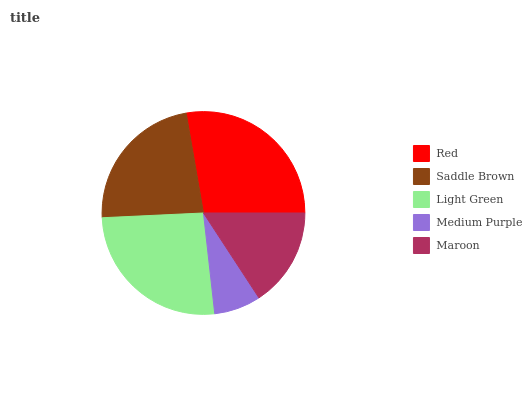Is Medium Purple the minimum?
Answer yes or no. Yes. Is Red the maximum?
Answer yes or no. Yes. Is Saddle Brown the minimum?
Answer yes or no. No. Is Saddle Brown the maximum?
Answer yes or no. No. Is Red greater than Saddle Brown?
Answer yes or no. Yes. Is Saddle Brown less than Red?
Answer yes or no. Yes. Is Saddle Brown greater than Red?
Answer yes or no. No. Is Red less than Saddle Brown?
Answer yes or no. No. Is Saddle Brown the high median?
Answer yes or no. Yes. Is Saddle Brown the low median?
Answer yes or no. Yes. Is Light Green the high median?
Answer yes or no. No. Is Medium Purple the low median?
Answer yes or no. No. 